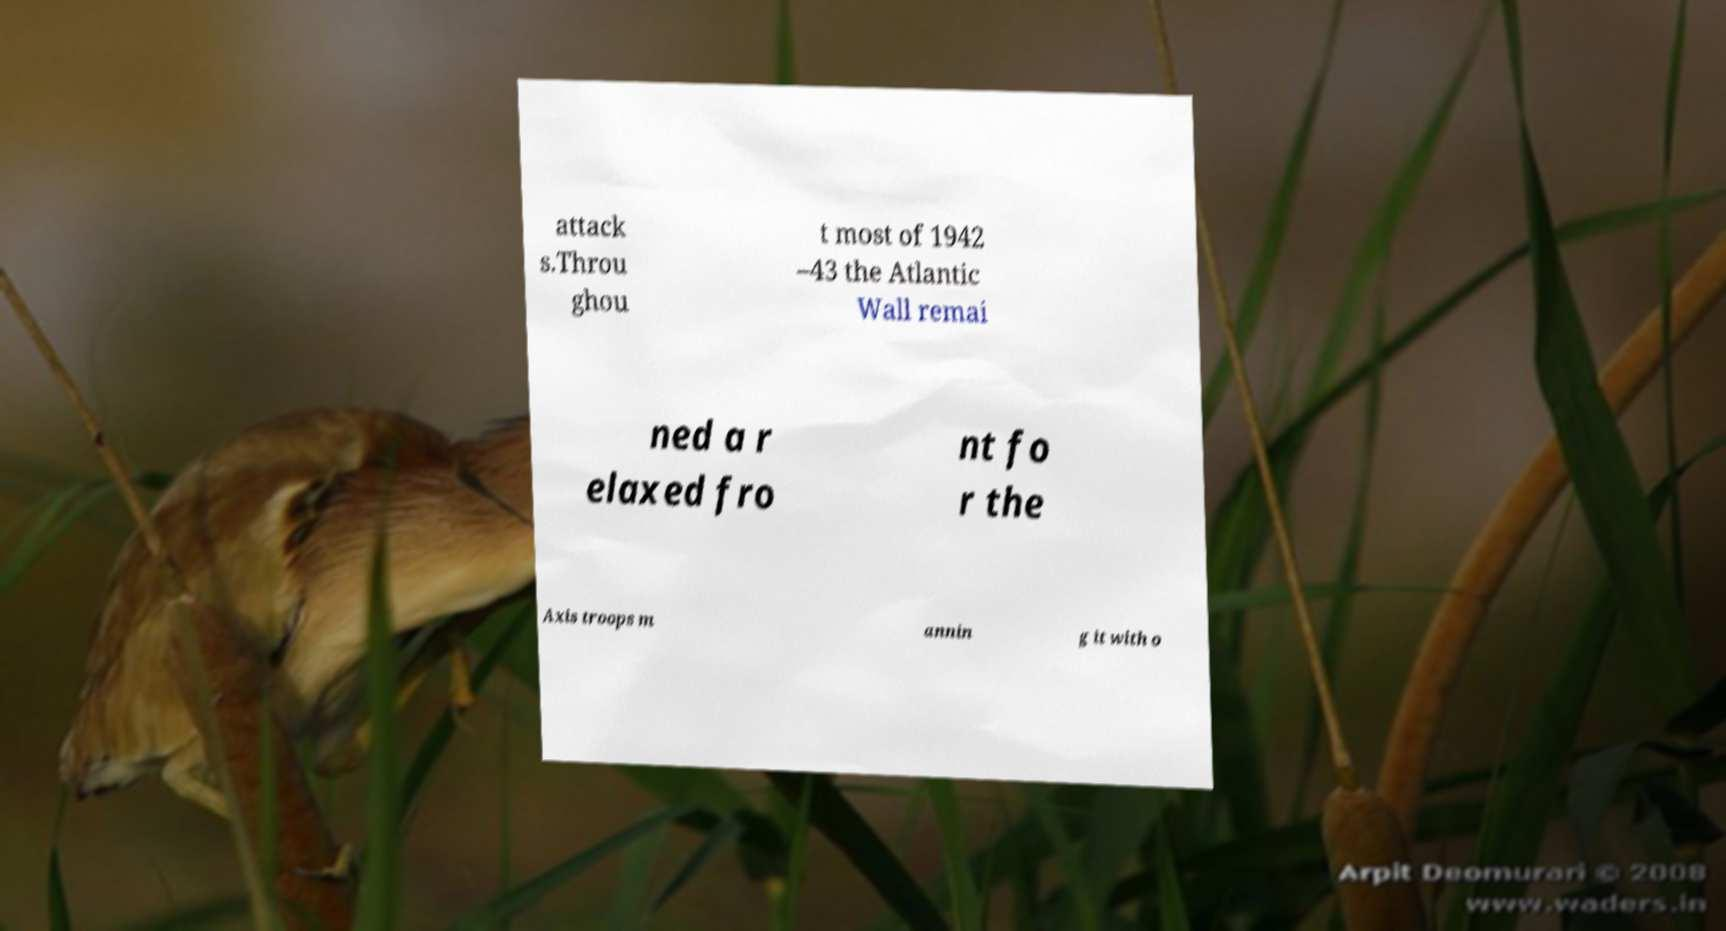Can you read and provide the text displayed in the image?This photo seems to have some interesting text. Can you extract and type it out for me? attack s.Throu ghou t most of 1942 –43 the Atlantic Wall remai ned a r elaxed fro nt fo r the Axis troops m annin g it with o 